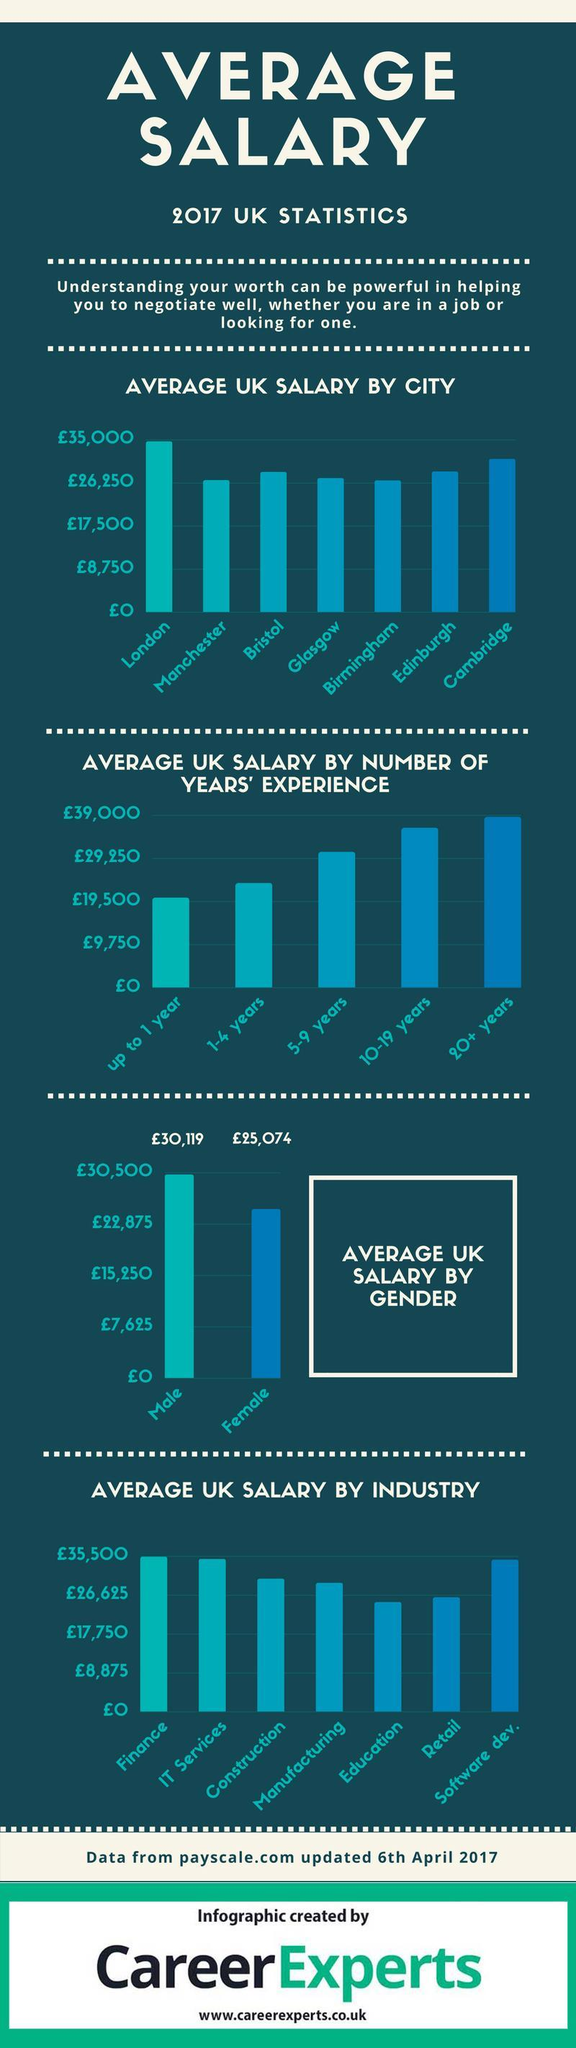People with how many years of experience is receiving the second highest salary in UK?
Answer the question with a short phrase. 10-19 years In which color Female average salary graph is drawn- red, pink, blue, green? blue Which Industry in UK provides the second least salary? Retail Which city in UK has third highest salary? Edinburgh Which Industry in UK provides the second highest salary? IT Services How many different category of experienced people are receiving salary less than 29,250 pound? 2 What is the difference between average salary of men and women in UK? 5,045 How many different category of experienced people are receiving salary greater than 29,250 pounds? 3 Which Industries in UK have average salary less than 26,625 pounds? Education, Retail Which city in UK has second highest salary? Cambridge 